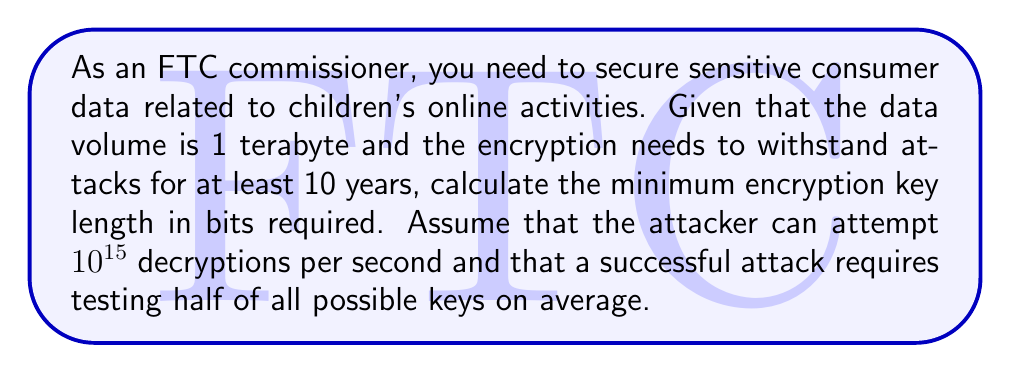Solve this math problem. To determine the minimum encryption key length, we need to follow these steps:

1. Calculate the total number of seconds in 10 years:
   $10 \text{ years} \times 365 \text{ days/year} \times 24 \text{ hours/day} \times 3600 \text{ seconds/hour} = 315,360,000 \text{ seconds}$

2. Calculate the total number of key attempts possible in 10 years:
   $315,360,000 \text{ seconds} \times 10^{15} \text{ attempts/second} = 3.1536 \times 10^{23} \text{ attempts}$

3. Since a successful attack requires testing half of all possible keys on average, we need to double this number:
   $3.1536 \times 10^{23} \times 2 = 6.3072 \times 10^{23}$

4. To find the key length in bits, we need to calculate the log base 2 of this number and round up to the nearest integer:
   $\text{Key length} = \lceil \log_2(6.3072 \times 10^{23}) \rceil$

5. Using a calculator or computer:
   $\log_2(6.3072 \times 10^{23}) \approx 78.95$

6. Rounding up to the nearest integer:
   $\lceil 78.95 \rceil = 79$

Therefore, the minimum encryption key length required is 79 bits. However, in practice, we would use the next standard key size, which is 128 bits, to provide an extra margin of security.
Answer: 128 bits 